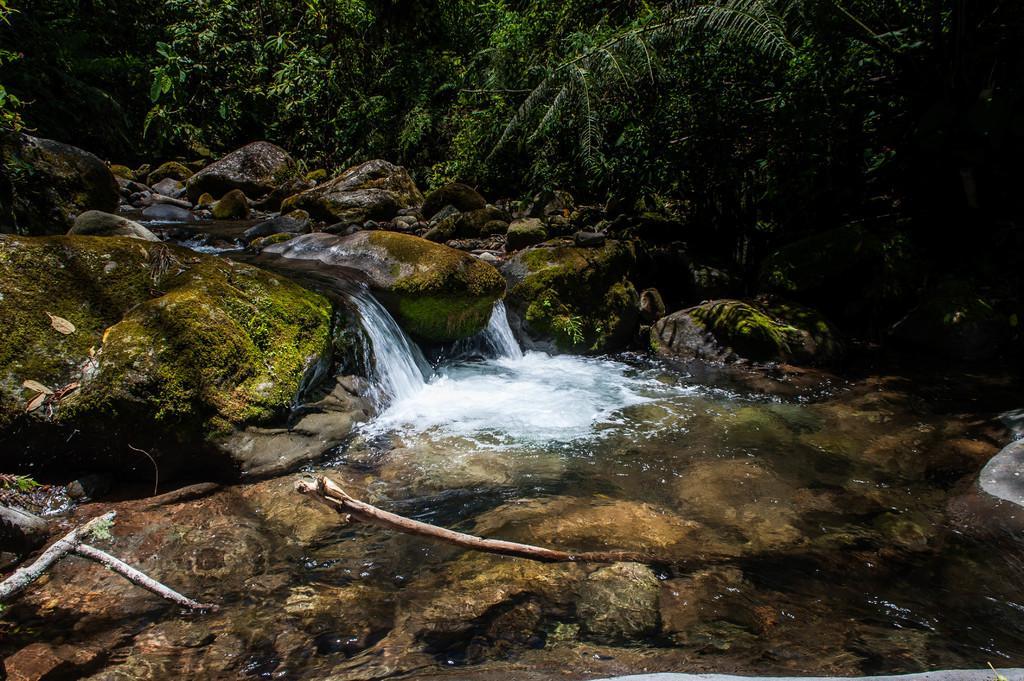How would you summarize this image in a sentence or two? This image is clicked outside. In the front, we can see a waterfall. At the bottom, there are rocks. In the background, there are trees. On the right, we can see the water flowing. 